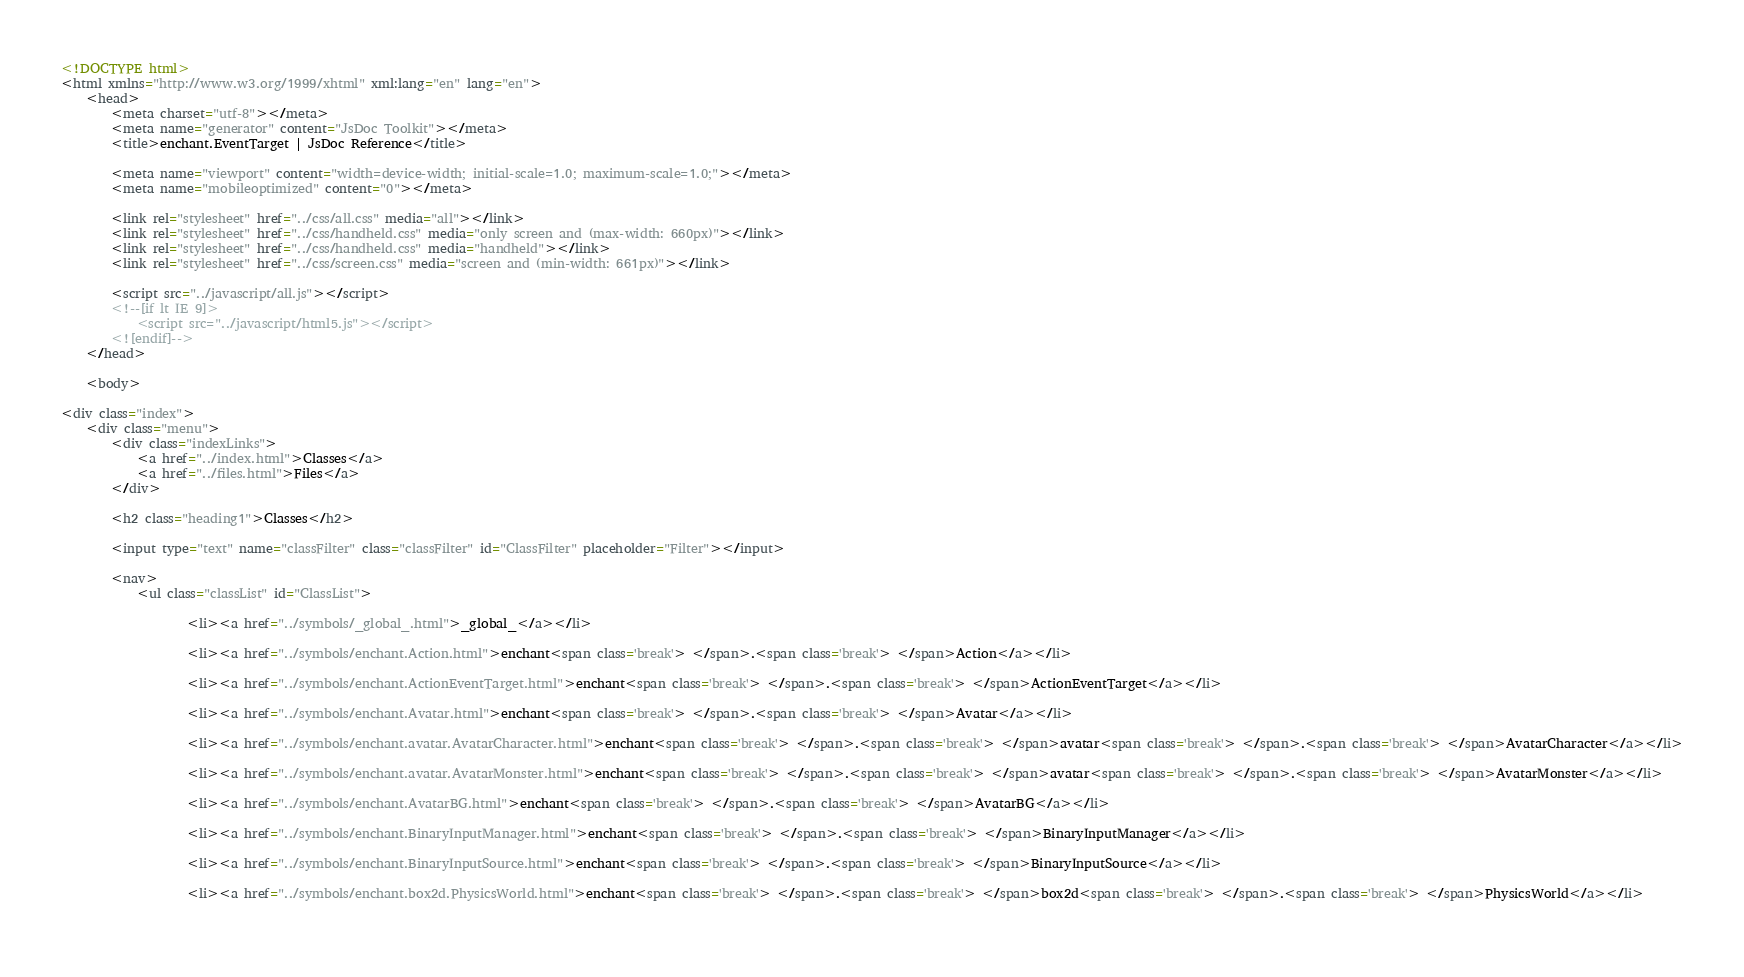Convert code to text. <code><loc_0><loc_0><loc_500><loc_500><_HTML_>
<!DOCTYPE html>
<html xmlns="http://www.w3.org/1999/xhtml" xml:lang="en" lang="en">
	<head>
		<meta charset="utf-8"></meta>
		<meta name="generator" content="JsDoc Toolkit"></meta>
		<title>enchant.EventTarget | JsDoc Reference</title>

		<meta name="viewport" content="width=device-width; initial-scale=1.0; maximum-scale=1.0;"></meta>
		<meta name="mobileoptimized" content="0"></meta>
	
		<link rel="stylesheet" href="../css/all.css" media="all"></link>
		<link rel="stylesheet" href="../css/handheld.css" media="only screen and (max-width: 660px)"></link>
		<link rel="stylesheet" href="../css/handheld.css" media="handheld"></link>
		<link rel="stylesheet" href="../css/screen.css" media="screen and (min-width: 661px)"></link>

		<script src="../javascript/all.js"></script>
		<!--[if lt IE 9]>
			<script src="../javascript/html5.js"></script>
		<![endif]-->
	</head>

	<body>

<div class="index">
	<div class="menu">
		<div class="indexLinks">
			<a href="../index.html">Classes</a>
			<a href="../files.html">Files</a>
		</div>
	
		<h2 class="heading1">Classes</h2>
		
		<input type="text" name="classFilter" class="classFilter" id="ClassFilter" placeholder="Filter"></input>
		
		<nav>
			<ul class="classList" id="ClassList">
				
					<li><a href="../symbols/_global_.html">_global_</a></li>
				
					<li><a href="../symbols/enchant.Action.html">enchant<span class='break'> </span>.<span class='break'> </span>Action</a></li>
				
					<li><a href="../symbols/enchant.ActionEventTarget.html">enchant<span class='break'> </span>.<span class='break'> </span>ActionEventTarget</a></li>
				
					<li><a href="../symbols/enchant.Avatar.html">enchant<span class='break'> </span>.<span class='break'> </span>Avatar</a></li>
				
					<li><a href="../symbols/enchant.avatar.AvatarCharacter.html">enchant<span class='break'> </span>.<span class='break'> </span>avatar<span class='break'> </span>.<span class='break'> </span>AvatarCharacter</a></li>
				
					<li><a href="../symbols/enchant.avatar.AvatarMonster.html">enchant<span class='break'> </span>.<span class='break'> </span>avatar<span class='break'> </span>.<span class='break'> </span>AvatarMonster</a></li>
				
					<li><a href="../symbols/enchant.AvatarBG.html">enchant<span class='break'> </span>.<span class='break'> </span>AvatarBG</a></li>
				
					<li><a href="../symbols/enchant.BinaryInputManager.html">enchant<span class='break'> </span>.<span class='break'> </span>BinaryInputManager</a></li>
				
					<li><a href="../symbols/enchant.BinaryInputSource.html">enchant<span class='break'> </span>.<span class='break'> </span>BinaryInputSource</a></li>
				
					<li><a href="../symbols/enchant.box2d.PhysicsWorld.html">enchant<span class='break'> </span>.<span class='break'> </span>box2d<span class='break'> </span>.<span class='break'> </span>PhysicsWorld</a></li>
				</code> 